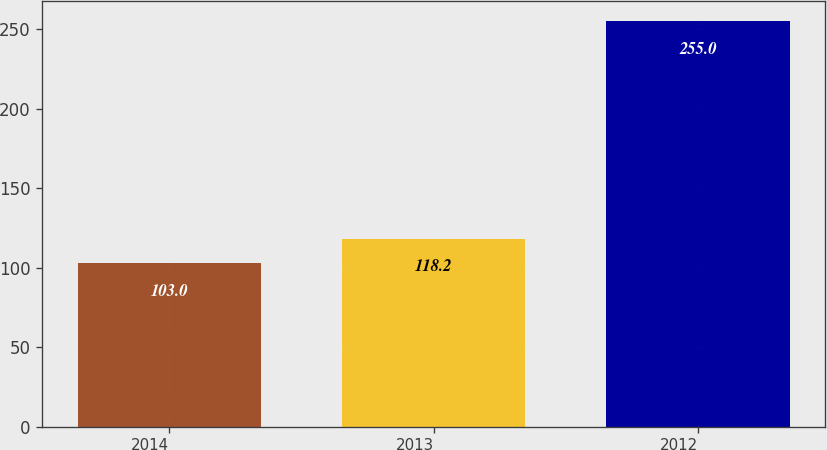Convert chart to OTSL. <chart><loc_0><loc_0><loc_500><loc_500><bar_chart><fcel>2014<fcel>2013<fcel>2012<nl><fcel>103<fcel>118.2<fcel>255<nl></chart> 